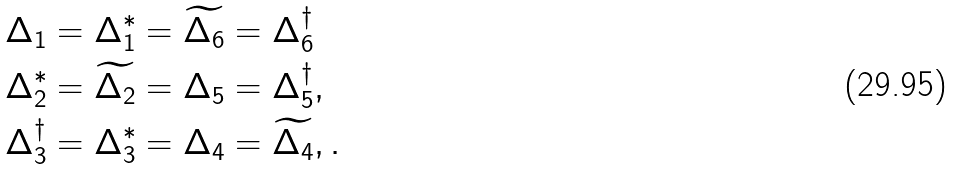Convert formula to latex. <formula><loc_0><loc_0><loc_500><loc_500>& \Delta _ { 1 } = \Delta _ { 1 } ^ { * } = \widetilde { \Delta _ { 6 } } = \Delta _ { 6 } ^ { \dagger } \\ & \Delta _ { 2 } ^ { * } = \widetilde { \Delta _ { 2 } } = \Delta _ { 5 } = \Delta _ { 5 } ^ { \dagger } , \\ & \Delta _ { 3 } ^ { \dagger } = \Delta _ { 3 } ^ { * } = \Delta _ { 4 } = \widetilde { \Delta _ { 4 } } , .</formula> 